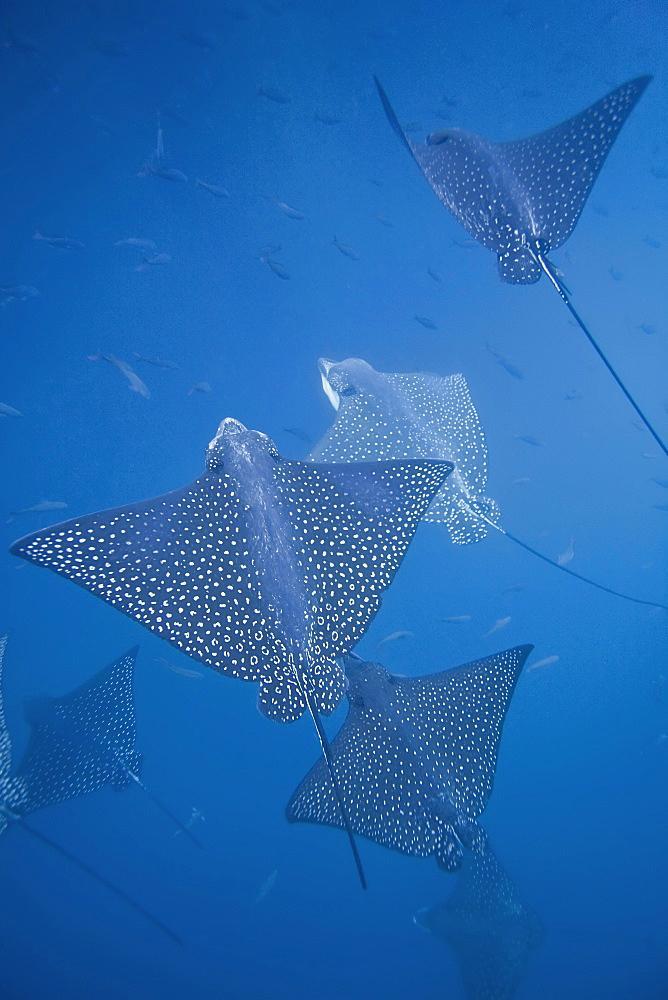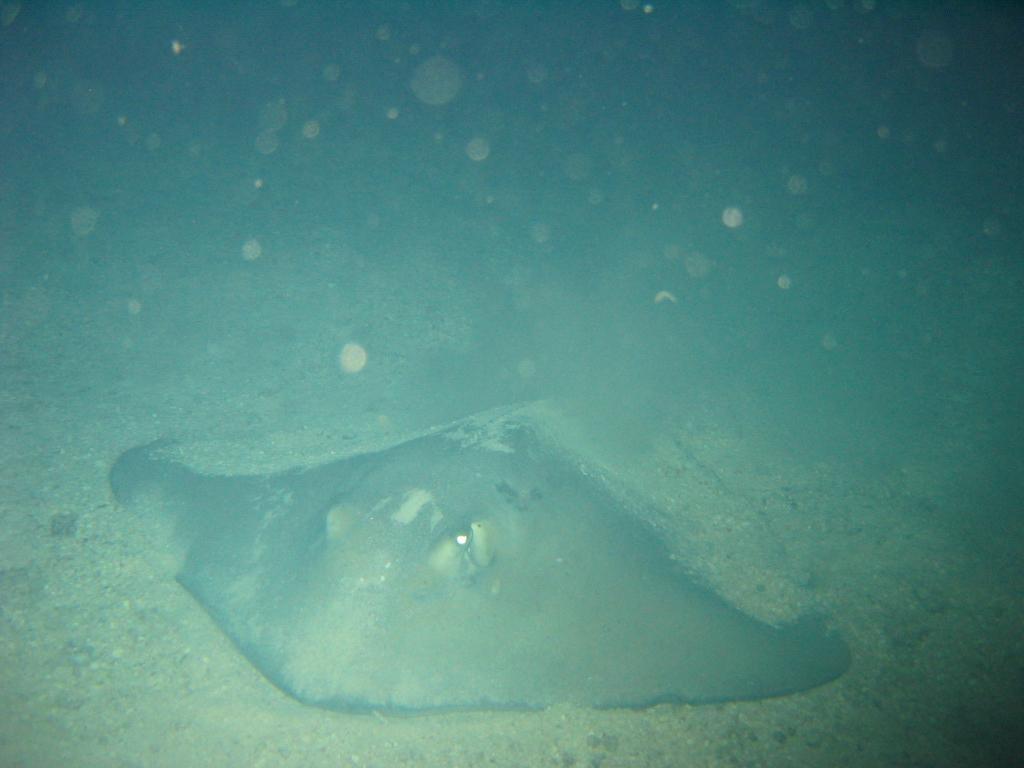The first image is the image on the left, the second image is the image on the right. Evaluate the accuracy of this statement regarding the images: "Both images include a stingray at the bottom of the ocean.". Is it true? Answer yes or no. No. The first image is the image on the left, the second image is the image on the right. For the images shown, is this caption "There are more rays in the image on the left than in the image on the right." true? Answer yes or no. Yes. 